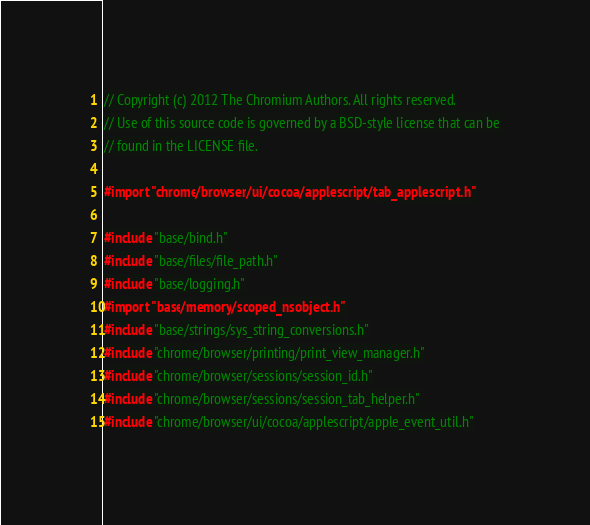<code> <loc_0><loc_0><loc_500><loc_500><_ObjectiveC_>// Copyright (c) 2012 The Chromium Authors. All rights reserved.
// Use of this source code is governed by a BSD-style license that can be
// found in the LICENSE file.

#import "chrome/browser/ui/cocoa/applescript/tab_applescript.h"

#include "base/bind.h"
#include "base/files/file_path.h"
#include "base/logging.h"
#import "base/memory/scoped_nsobject.h"
#include "base/strings/sys_string_conversions.h"
#include "chrome/browser/printing/print_view_manager.h"
#include "chrome/browser/sessions/session_id.h"
#include "chrome/browser/sessions/session_tab_helper.h"
#include "chrome/browser/ui/cocoa/applescript/apple_event_util.h"</code> 